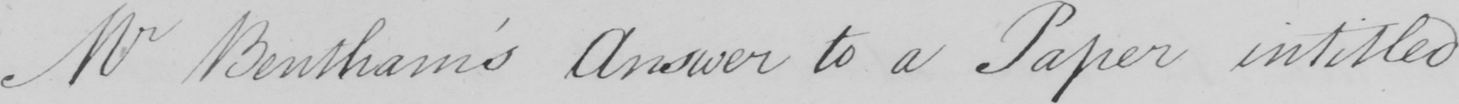What is written in this line of handwriting? Mr Bentham ' s Answer to a Paper intitled 